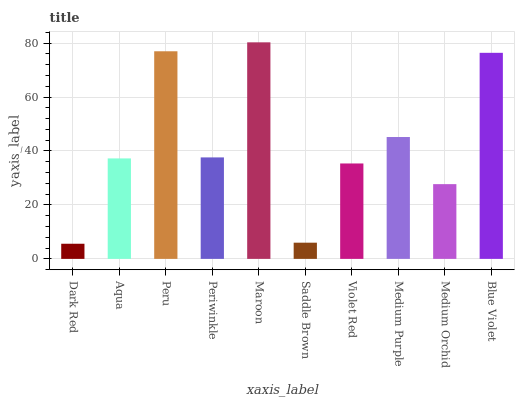Is Dark Red the minimum?
Answer yes or no. Yes. Is Maroon the maximum?
Answer yes or no. Yes. Is Aqua the minimum?
Answer yes or no. No. Is Aqua the maximum?
Answer yes or no. No. Is Aqua greater than Dark Red?
Answer yes or no. Yes. Is Dark Red less than Aqua?
Answer yes or no. Yes. Is Dark Red greater than Aqua?
Answer yes or no. No. Is Aqua less than Dark Red?
Answer yes or no. No. Is Periwinkle the high median?
Answer yes or no. Yes. Is Aqua the low median?
Answer yes or no. Yes. Is Peru the high median?
Answer yes or no. No. Is Dark Red the low median?
Answer yes or no. No. 